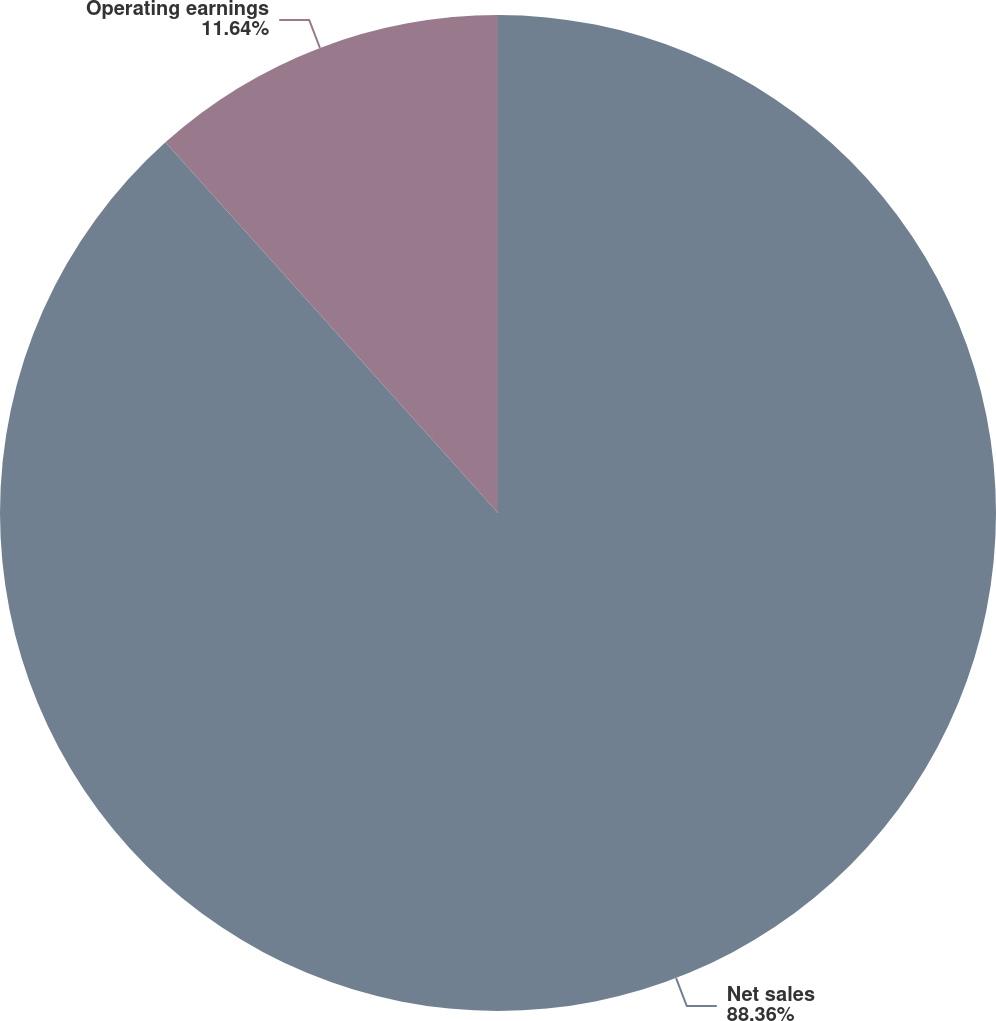Convert chart to OTSL. <chart><loc_0><loc_0><loc_500><loc_500><pie_chart><fcel>Net sales<fcel>Operating earnings<nl><fcel>88.36%<fcel>11.64%<nl></chart> 